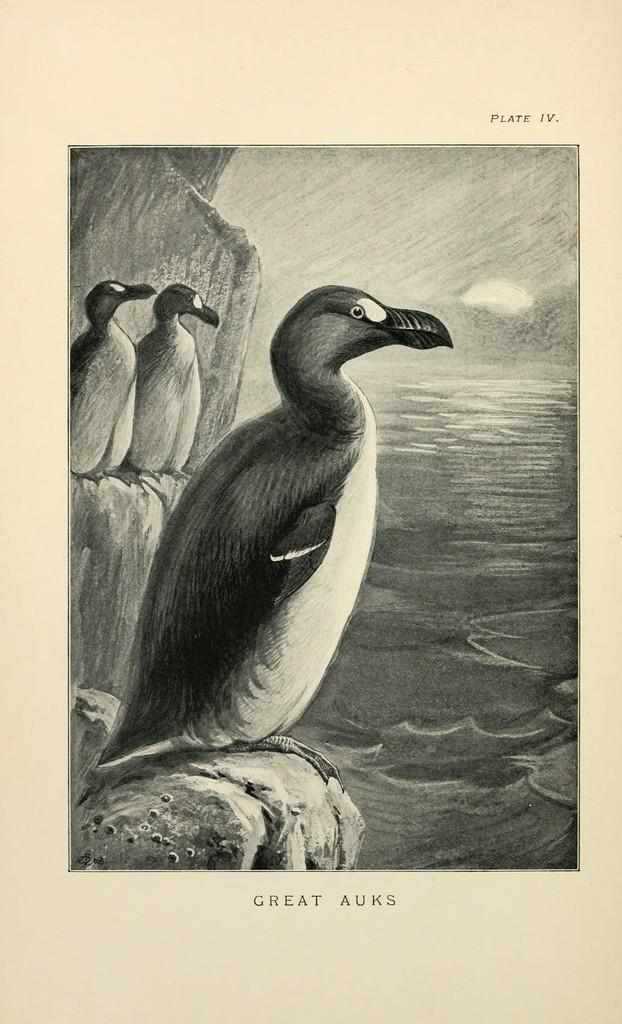What is the main subject of the image? The main subject of the image is a cover of a book. What can be seen on the book cover? There are pictures and text visible on the book cover. How many legs can be seen on the book cover in the image? There are no legs visible on the book cover in the image. What type of slope is present on the book cover in the image? There is no slope present on the book cover in the image. Can you see a tail on the book cover in the image? There is no tail present on the book cover in the image. 